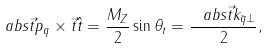Convert formula to latex. <formula><loc_0><loc_0><loc_500><loc_500>\ a b s { \vec { t } { p } _ { q } \times \vec { t } { \hat { t } } } = \frac { M _ { Z } } { 2 } \sin \theta _ { t } = \frac { \ a b s { \vec { t } { k } _ { \bar { q } \perp } } } { 2 } ,</formula> 